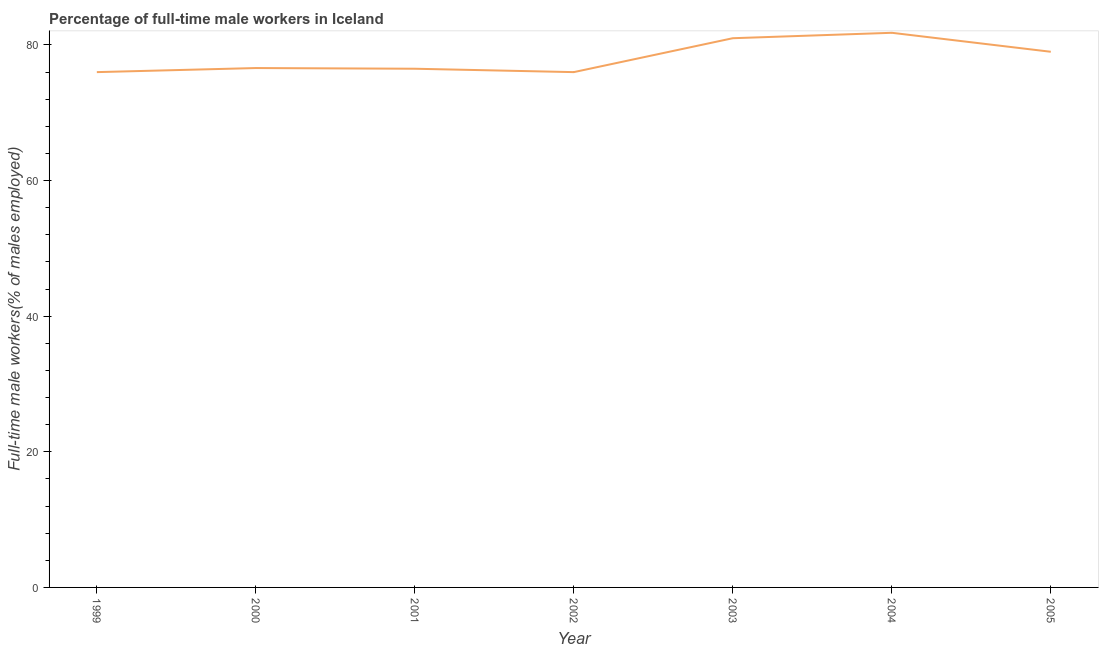What is the percentage of full-time male workers in 2001?
Give a very brief answer. 76.5. Across all years, what is the maximum percentage of full-time male workers?
Your answer should be compact. 81.8. In which year was the percentage of full-time male workers minimum?
Your answer should be compact. 1999. What is the sum of the percentage of full-time male workers?
Your answer should be very brief. 546.9. What is the difference between the percentage of full-time male workers in 2000 and 2005?
Make the answer very short. -2.4. What is the average percentage of full-time male workers per year?
Your answer should be very brief. 78.13. What is the median percentage of full-time male workers?
Your response must be concise. 76.6. Do a majority of the years between 1999 and 2003 (inclusive) have percentage of full-time male workers greater than 24 %?
Your answer should be very brief. Yes. What is the ratio of the percentage of full-time male workers in 1999 to that in 2003?
Offer a very short reply. 0.94. Is the percentage of full-time male workers in 1999 less than that in 2002?
Your answer should be very brief. No. Is the difference between the percentage of full-time male workers in 1999 and 2003 greater than the difference between any two years?
Your response must be concise. No. What is the difference between the highest and the second highest percentage of full-time male workers?
Ensure brevity in your answer.  0.8. Is the sum of the percentage of full-time male workers in 2000 and 2002 greater than the maximum percentage of full-time male workers across all years?
Offer a very short reply. Yes. What is the difference between the highest and the lowest percentage of full-time male workers?
Provide a succinct answer. 5.8. In how many years, is the percentage of full-time male workers greater than the average percentage of full-time male workers taken over all years?
Your answer should be compact. 3. How many years are there in the graph?
Give a very brief answer. 7. What is the difference between two consecutive major ticks on the Y-axis?
Ensure brevity in your answer.  20. Does the graph contain any zero values?
Your answer should be very brief. No. Does the graph contain grids?
Provide a short and direct response. No. What is the title of the graph?
Your answer should be very brief. Percentage of full-time male workers in Iceland. What is the label or title of the Y-axis?
Your answer should be very brief. Full-time male workers(% of males employed). What is the Full-time male workers(% of males employed) of 1999?
Your answer should be very brief. 76. What is the Full-time male workers(% of males employed) of 2000?
Provide a succinct answer. 76.6. What is the Full-time male workers(% of males employed) in 2001?
Your answer should be compact. 76.5. What is the Full-time male workers(% of males employed) of 2003?
Provide a short and direct response. 81. What is the Full-time male workers(% of males employed) in 2004?
Give a very brief answer. 81.8. What is the Full-time male workers(% of males employed) of 2005?
Make the answer very short. 79. What is the difference between the Full-time male workers(% of males employed) in 1999 and 2000?
Ensure brevity in your answer.  -0.6. What is the difference between the Full-time male workers(% of males employed) in 1999 and 2003?
Provide a succinct answer. -5. What is the difference between the Full-time male workers(% of males employed) in 1999 and 2004?
Ensure brevity in your answer.  -5.8. What is the difference between the Full-time male workers(% of males employed) in 1999 and 2005?
Offer a terse response. -3. What is the difference between the Full-time male workers(% of males employed) in 2000 and 2001?
Provide a succinct answer. 0.1. What is the difference between the Full-time male workers(% of males employed) in 2000 and 2002?
Keep it short and to the point. 0.6. What is the difference between the Full-time male workers(% of males employed) in 2000 and 2003?
Your response must be concise. -4.4. What is the difference between the Full-time male workers(% of males employed) in 2000 and 2004?
Offer a very short reply. -5.2. What is the difference between the Full-time male workers(% of males employed) in 2002 and 2003?
Give a very brief answer. -5. What is the difference between the Full-time male workers(% of males employed) in 2002 and 2004?
Offer a terse response. -5.8. What is the difference between the Full-time male workers(% of males employed) in 2003 and 2004?
Offer a very short reply. -0.8. What is the difference between the Full-time male workers(% of males employed) in 2004 and 2005?
Provide a short and direct response. 2.8. What is the ratio of the Full-time male workers(% of males employed) in 1999 to that in 2002?
Make the answer very short. 1. What is the ratio of the Full-time male workers(% of males employed) in 1999 to that in 2003?
Your response must be concise. 0.94. What is the ratio of the Full-time male workers(% of males employed) in 1999 to that in 2004?
Provide a short and direct response. 0.93. What is the ratio of the Full-time male workers(% of males employed) in 1999 to that in 2005?
Your answer should be compact. 0.96. What is the ratio of the Full-time male workers(% of males employed) in 2000 to that in 2001?
Provide a short and direct response. 1. What is the ratio of the Full-time male workers(% of males employed) in 2000 to that in 2002?
Provide a succinct answer. 1.01. What is the ratio of the Full-time male workers(% of males employed) in 2000 to that in 2003?
Offer a very short reply. 0.95. What is the ratio of the Full-time male workers(% of males employed) in 2000 to that in 2004?
Ensure brevity in your answer.  0.94. What is the ratio of the Full-time male workers(% of males employed) in 2001 to that in 2003?
Your answer should be compact. 0.94. What is the ratio of the Full-time male workers(% of males employed) in 2001 to that in 2004?
Offer a very short reply. 0.94. What is the ratio of the Full-time male workers(% of males employed) in 2001 to that in 2005?
Give a very brief answer. 0.97. What is the ratio of the Full-time male workers(% of males employed) in 2002 to that in 2003?
Offer a very short reply. 0.94. What is the ratio of the Full-time male workers(% of males employed) in 2002 to that in 2004?
Your answer should be very brief. 0.93. What is the ratio of the Full-time male workers(% of males employed) in 2002 to that in 2005?
Provide a succinct answer. 0.96. What is the ratio of the Full-time male workers(% of males employed) in 2003 to that in 2004?
Keep it short and to the point. 0.99. What is the ratio of the Full-time male workers(% of males employed) in 2003 to that in 2005?
Keep it short and to the point. 1.02. What is the ratio of the Full-time male workers(% of males employed) in 2004 to that in 2005?
Your response must be concise. 1.03. 